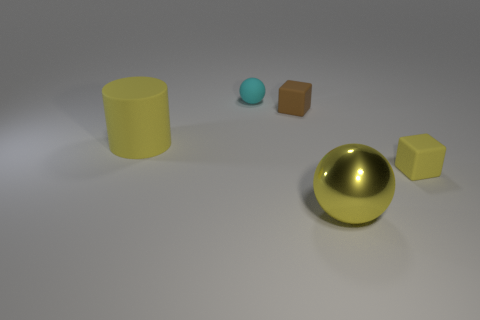Add 4 big yellow objects. How many objects exist? 9 Subtract all blocks. How many objects are left? 3 Add 3 yellow matte objects. How many yellow matte objects exist? 5 Subtract 0 cyan cubes. How many objects are left? 5 Subtract all tiny gray objects. Subtract all matte things. How many objects are left? 1 Add 5 small cyan matte things. How many small cyan matte things are left? 6 